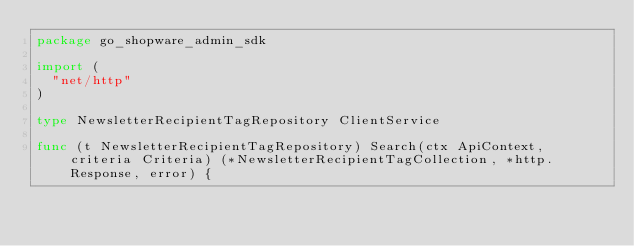<code> <loc_0><loc_0><loc_500><loc_500><_Go_>package go_shopware_admin_sdk

import (
	"net/http"
)

type NewsletterRecipientTagRepository ClientService

func (t NewsletterRecipientTagRepository) Search(ctx ApiContext, criteria Criteria) (*NewsletterRecipientTagCollection, *http.Response, error) {</code> 